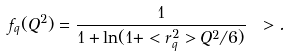<formula> <loc_0><loc_0><loc_500><loc_500>f _ { q } ( Q ^ { 2 } ) = \frac { 1 } { 1 + \ln ( 1 + < r ^ { 2 } _ { q } > Q ^ { 2 } / 6 ) } \ > .</formula> 